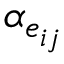<formula> <loc_0><loc_0><loc_500><loc_500>\alpha _ { e _ { i j } }</formula> 